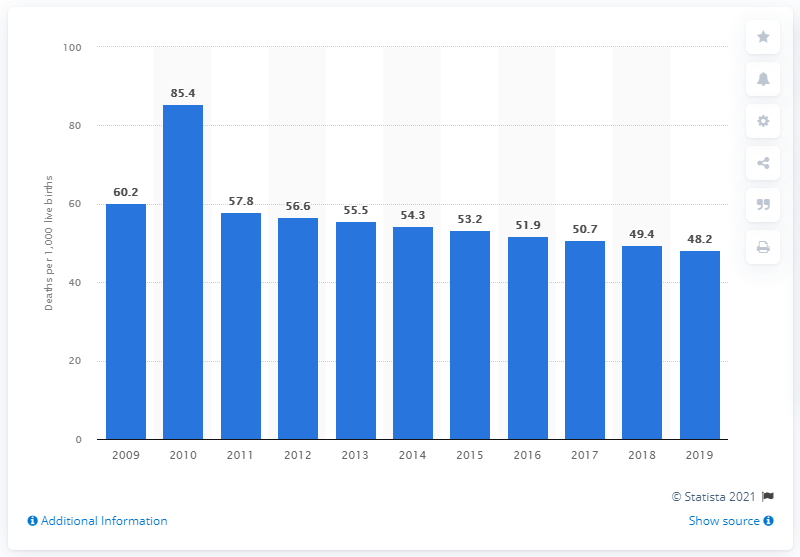Draw attention to some important aspects in this diagram. According to data from 2019, the infant mortality rate in Haiti was 48.2. 